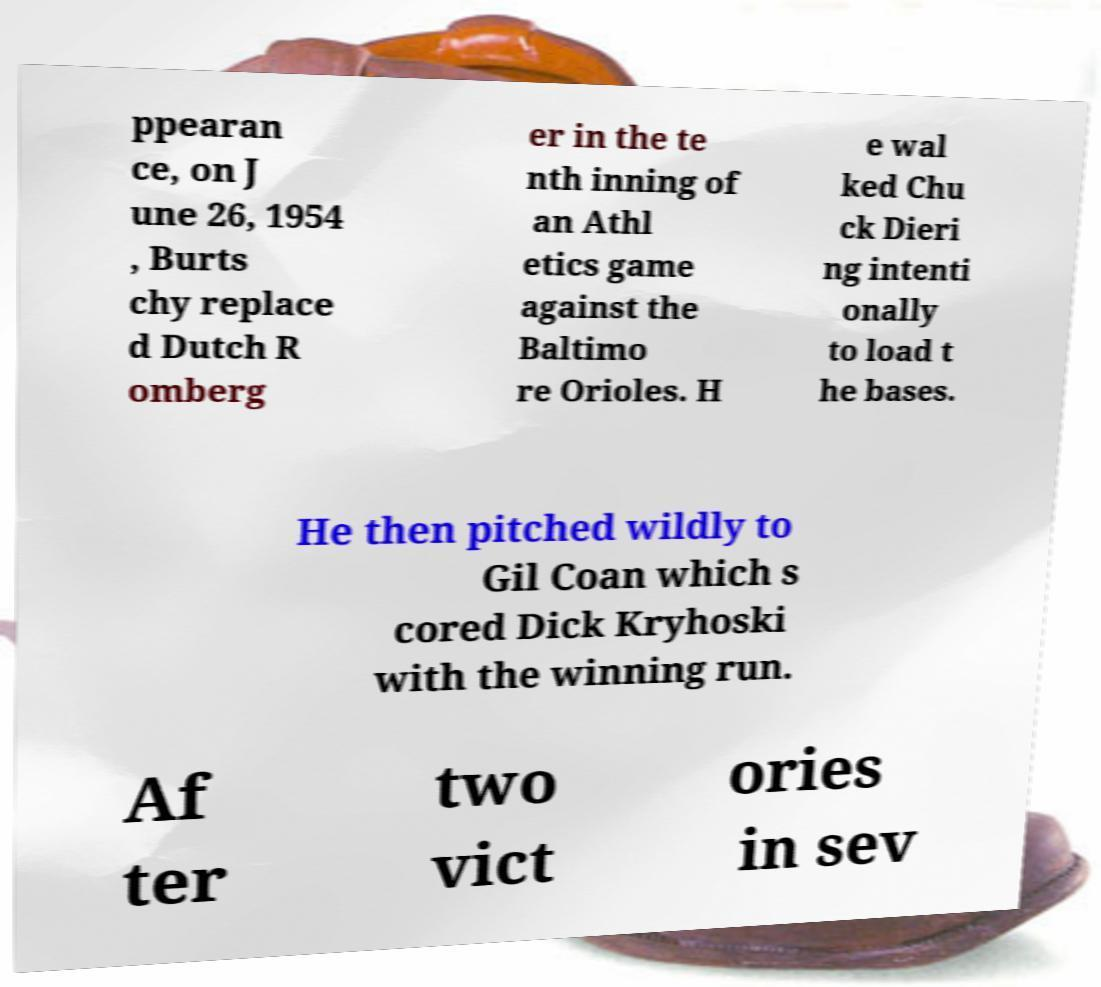Can you read and provide the text displayed in the image?This photo seems to have some interesting text. Can you extract and type it out for me? ppearan ce, on J une 26, 1954 , Burts chy replace d Dutch R omberg er in the te nth inning of an Athl etics game against the Baltimo re Orioles. H e wal ked Chu ck Dieri ng intenti onally to load t he bases. He then pitched wildly to Gil Coan which s cored Dick Kryhoski with the winning run. Af ter two vict ories in sev 